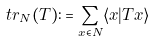<formula> <loc_0><loc_0><loc_500><loc_500>t r _ { N } ( T ) \colon = \sum _ { x \in N } \langle x | T x \rangle</formula> 